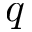<formula> <loc_0><loc_0><loc_500><loc_500>q</formula> 